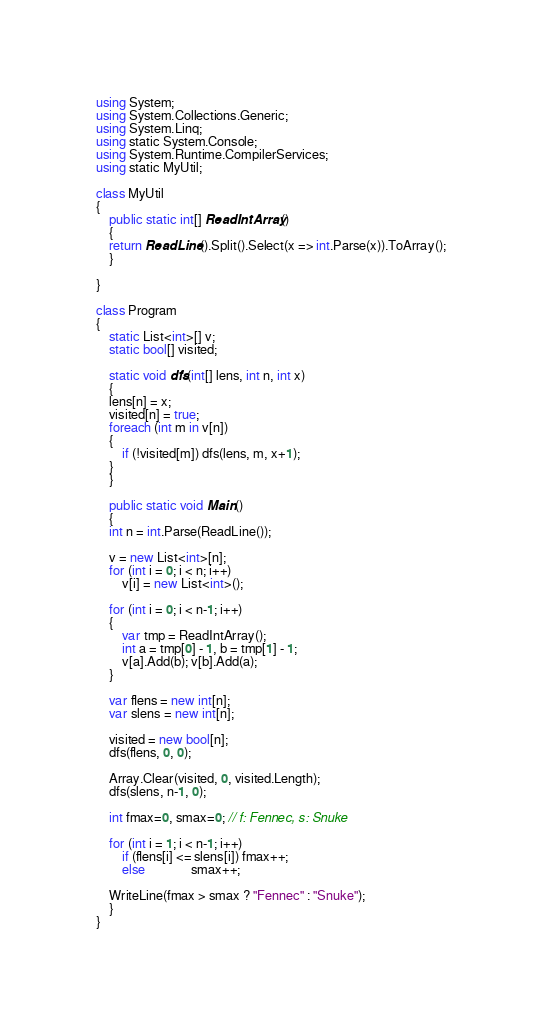<code> <loc_0><loc_0><loc_500><loc_500><_C#_>using System;
using System.Collections.Generic;
using System.Linq;
using static System.Console;
using System.Runtime.CompilerServices;
using static MyUtil;

class MyUtil
{
    public static int[] ReadIntArray()
    {
	return ReadLine().Split().Select(x => int.Parse(x)).ToArray();
    }

}

class Program
{
    static List<int>[] v;
    static bool[] visited;

    static void dfs(int[] lens, int n, int x)
    {
	lens[n] = x;
	visited[n] = true;
	foreach (int m in v[n])
	{
	    if (!visited[m]) dfs(lens, m, x+1);
	}
    }
    
    public static void Main()
    {
	int n = int.Parse(ReadLine());

	v = new List<int>[n];
	for (int i = 0; i < n; i++)
	    v[i] = new List<int>();
	
	for (int i = 0; i < n-1; i++)
	{
	    var tmp = ReadIntArray();
	    int a = tmp[0] - 1, b = tmp[1] - 1;
	    v[a].Add(b); v[b].Add(a);
	}

	var flens = new int[n];
	var slens = new int[n];

	visited = new bool[n];
	dfs(flens, 0, 0);

	Array.Clear(visited, 0, visited.Length);
	dfs(slens, n-1, 0);

	int fmax=0, smax=0; // f: Fennec, s: Snuke

	for (int i = 1; i < n-1; i++)
	    if (flens[i] <= slens[i]) fmax++;
	    else		      smax++;

	WriteLine(fmax > smax ? "Fennec" : "Snuke");
    }
}
</code> 